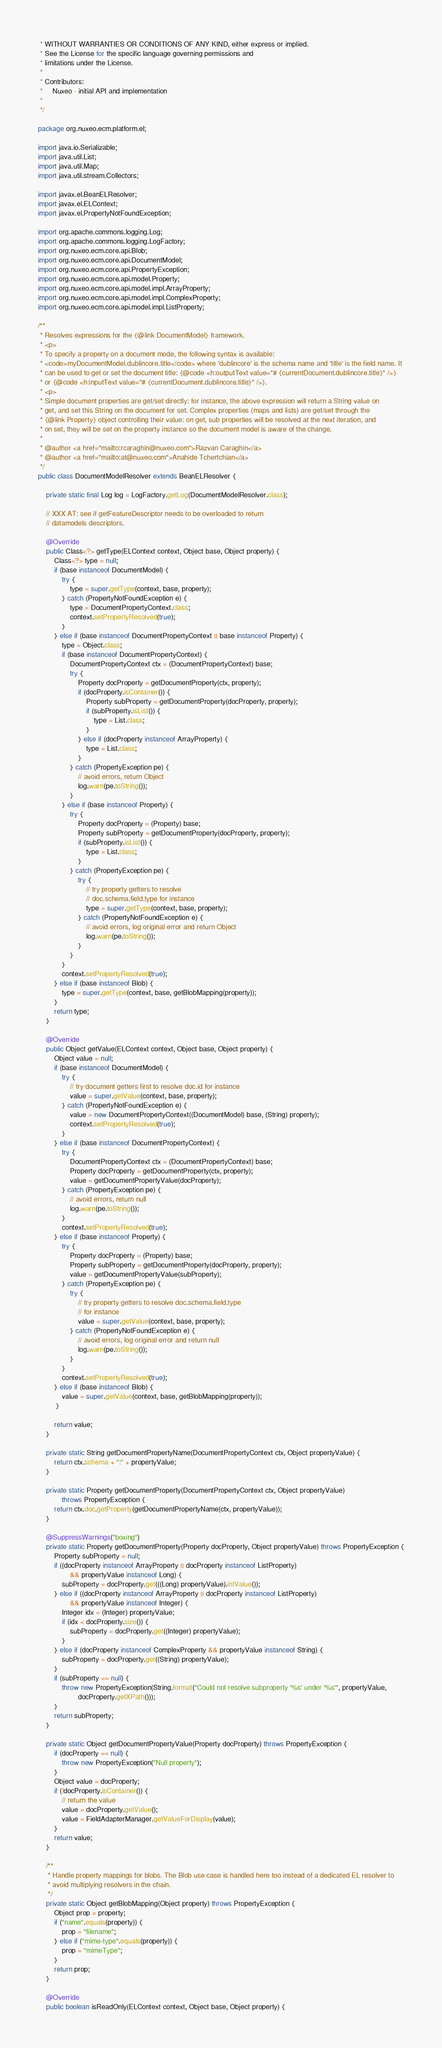<code> <loc_0><loc_0><loc_500><loc_500><_Java_> * WITHOUT WARRANTIES OR CONDITIONS OF ANY KIND, either express or implied.
 * See the License for the specific language governing permissions and
 * limitations under the License.
 *
 * Contributors:
 *     Nuxeo - initial API and implementation
 *
 */

package org.nuxeo.ecm.platform.el;

import java.io.Serializable;
import java.util.List;
import java.util.Map;
import java.util.stream.Collectors;

import javax.el.BeanELResolver;
import javax.el.ELContext;
import javax.el.PropertyNotFoundException;

import org.apache.commons.logging.Log;
import org.apache.commons.logging.LogFactory;
import org.nuxeo.ecm.core.api.Blob;
import org.nuxeo.ecm.core.api.DocumentModel;
import org.nuxeo.ecm.core.api.PropertyException;
import org.nuxeo.ecm.core.api.model.Property;
import org.nuxeo.ecm.core.api.model.impl.ArrayProperty;
import org.nuxeo.ecm.core.api.model.impl.ComplexProperty;
import org.nuxeo.ecm.core.api.model.impl.ListProperty;

/**
 * Resolves expressions for the {@link DocumentModel} framework.
 * <p>
 * To specify a property on a document mode, the following syntax is available:
 * <code>myDocumentModel.dublincore.title</code> where 'dublincore' is the schema name and 'title' is the field name. It
 * can be used to get or set the document title: {@code <h:outputText value="# {currentDocument.dublincore.title}" />}
 * or {@code <h:inputText value="# {currentDocument.dublincore.title}" />}.
 * <p>
 * Simple document properties are get/set directly: for instance, the above expression will return a String value on
 * get, and set this String on the document for set. Complex properties (maps and lists) are get/set through the
 * {@link Property} object controlling their value: on get, sub properties will be resolved at the next iteration, and
 * on set, they will be set on the property instance so the document model is aware of the change.
 *
 * @author <a href="mailto:rcaraghin@nuxeo.com">Razvan Caraghin</a>
 * @author <a href="mailto:at@nuxeo.com">Anahide Tchertchian</a>
 */
public class DocumentModelResolver extends BeanELResolver {

    private static final Log log = LogFactory.getLog(DocumentModelResolver.class);

    // XXX AT: see if getFeatureDescriptor needs to be overloaded to return
    // datamodels descriptors.

    @Override
    public Class<?> getType(ELContext context, Object base, Object property) {
        Class<?> type = null;
        if (base instanceof DocumentModel) {
            try {
                type = super.getType(context, base, property);
            } catch (PropertyNotFoundException e) {
                type = DocumentPropertyContext.class;
                context.setPropertyResolved(true);
            }
        } else if (base instanceof DocumentPropertyContext || base instanceof Property) {
            type = Object.class;
            if (base instanceof DocumentPropertyContext) {
                DocumentPropertyContext ctx = (DocumentPropertyContext) base;
                try {
                    Property docProperty = getDocumentProperty(ctx, property);
                    if (docProperty.isContainer()) {
                        Property subProperty = getDocumentProperty(docProperty, property);
                        if (subProperty.isList()) {
                            type = List.class;
                        }
                    } else if (docProperty instanceof ArrayProperty) {
                        type = List.class;
                    }
                } catch (PropertyException pe) {
                    // avoid errors, return Object
                    log.warn(pe.toString());
                }
            } else if (base instanceof Property) {
                try {
                    Property docProperty = (Property) base;
                    Property subProperty = getDocumentProperty(docProperty, property);
                    if (subProperty.isList()) {
                        type = List.class;
                    }
                } catch (PropertyException pe) {
                    try {
                        // try property getters to resolve
                        // doc.schema.field.type for instance
                        type = super.getType(context, base, property);
                    } catch (PropertyNotFoundException e) {
                        // avoid errors, log original error and return Object
                        log.warn(pe.toString());
                    }
                }
            }
            context.setPropertyResolved(true);
        } else if (base instanceof Blob) {
            type = super.getType(context, base, getBlobMapping(property));
        }
        return type;
    }

    @Override
    public Object getValue(ELContext context, Object base, Object property) {
        Object value = null;
        if (base instanceof DocumentModel) {
            try {
                // try document getters first to resolve doc.id for instance
                value = super.getValue(context, base, property);
            } catch (PropertyNotFoundException e) {
                value = new DocumentPropertyContext((DocumentModel) base, (String) property);
                context.setPropertyResolved(true);
            }
        } else if (base instanceof DocumentPropertyContext) {
            try {
                DocumentPropertyContext ctx = (DocumentPropertyContext) base;
                Property docProperty = getDocumentProperty(ctx, property);
                value = getDocumentPropertyValue(docProperty);
            } catch (PropertyException pe) {
                // avoid errors, return null
                log.warn(pe.toString());
            }
            context.setPropertyResolved(true);
        } else if (base instanceof Property) {
            try {
                Property docProperty = (Property) base;
                Property subProperty = getDocumentProperty(docProperty, property);
                value = getDocumentPropertyValue(subProperty);
            } catch (PropertyException pe) {
                try {
                    // try property getters to resolve doc.schema.field.type
                    // for instance
                    value = super.getValue(context, base, property);
                } catch (PropertyNotFoundException e) {
                    // avoid errors, log original error and return null
                    log.warn(pe.toString());
                }
            }
            context.setPropertyResolved(true);
        } else if (base instanceof Blob) {
            value = super.getValue(context, base, getBlobMapping(property));
         }

        return value;
    }

    private static String getDocumentPropertyName(DocumentPropertyContext ctx, Object propertyValue) {
        return ctx.schema + ":" + propertyValue;
    }

    private static Property getDocumentProperty(DocumentPropertyContext ctx, Object propertyValue)
            throws PropertyException {
        return ctx.doc.getProperty(getDocumentPropertyName(ctx, propertyValue));
    }

    @SuppressWarnings("boxing")
    private static Property getDocumentProperty(Property docProperty, Object propertyValue) throws PropertyException {
        Property subProperty = null;
        if ((docProperty instanceof ArrayProperty || docProperty instanceof ListProperty)
                && propertyValue instanceof Long) {
            subProperty = docProperty.get(((Long) propertyValue).intValue());
        } else if ((docProperty instanceof ArrayProperty || docProperty instanceof ListProperty)
                && propertyValue instanceof Integer) {
            Integer idx = (Integer) propertyValue;
            if (idx < docProperty.size()) {
                subProperty = docProperty.get((Integer) propertyValue);
            }
        } else if (docProperty instanceof ComplexProperty && propertyValue instanceof String) {
            subProperty = docProperty.get((String) propertyValue);
        }
        if (subProperty == null) {
            throw new PropertyException(String.format("Could not resolve subproperty '%s' under '%s'", propertyValue,
                    docProperty.getXPath()));
        }
        return subProperty;
    }

    private static Object getDocumentPropertyValue(Property docProperty) throws PropertyException {
        if (docProperty == null) {
            throw new PropertyException("Null property");
        }
        Object value = docProperty;
        if (!docProperty.isContainer()) {
            // return the value
            value = docProperty.getValue();
            value = FieldAdapterManager.getValueForDisplay(value);
        }
        return value;
    }

    /**
     * Handle property mappings for blobs. The Blob use case is handled here too instead of a dedicated EL resolver to
     * avoid multiplying resolvers in the chain.
     */
    private static Object getBlobMapping(Object property) throws PropertyException {
        Object prop = property;
        if ("name".equals(property)) {
            prop = "filename";
        } else if ("mime-type".equals(property)) {
            prop = "mimeType";
        }
        return prop;
    }

    @Override
    public boolean isReadOnly(ELContext context, Object base, Object property) {</code> 